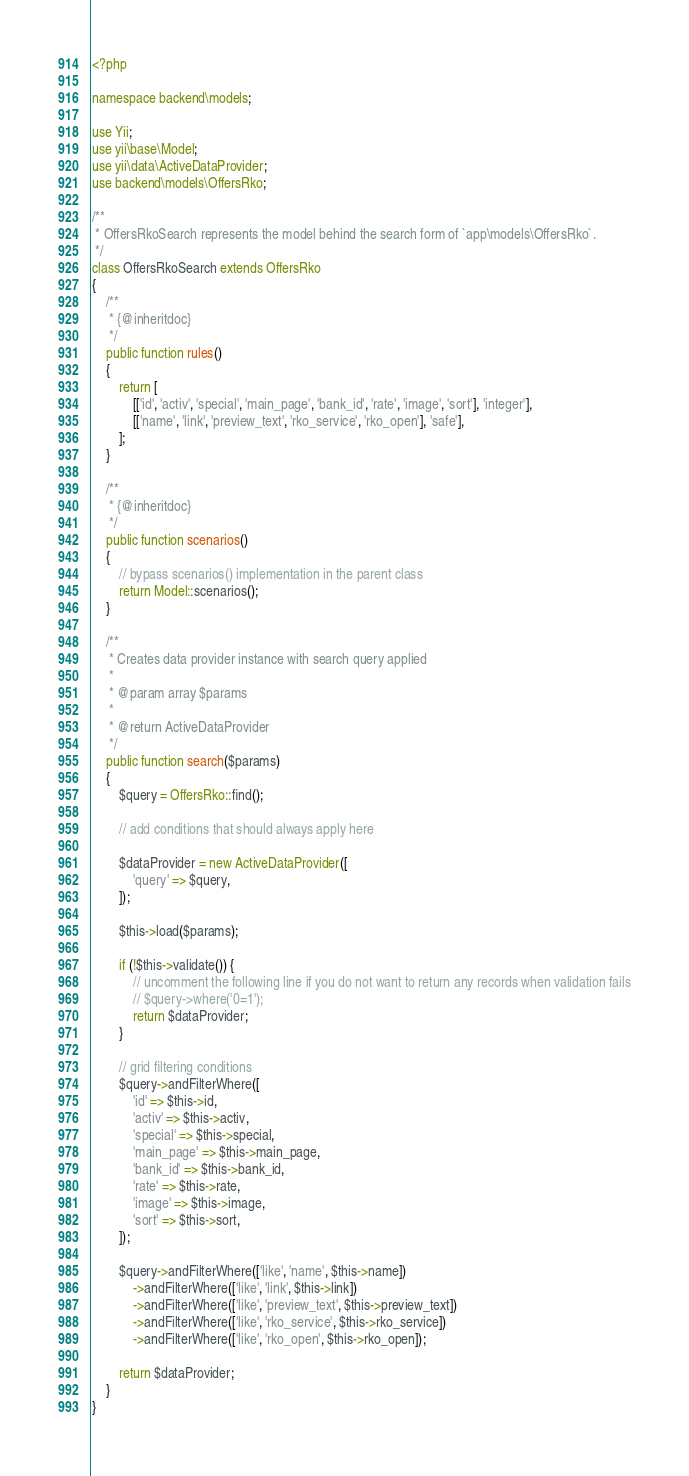Convert code to text. <code><loc_0><loc_0><loc_500><loc_500><_PHP_><?php

namespace backend\models;

use Yii;
use yii\base\Model;
use yii\data\ActiveDataProvider;
use backend\models\OffersRko;

/**
 * OffersRkoSearch represents the model behind the search form of `app\models\OffersRko`.
 */
class OffersRkoSearch extends OffersRko
{
    /**
     * {@inheritdoc}
     */
    public function rules()
    {
        return [
            [['id', 'activ', 'special', 'main_page', 'bank_id', 'rate', 'image', 'sort'], 'integer'],
            [['name', 'link', 'preview_text', 'rko_service', 'rko_open'], 'safe'],
        ];
    }

    /**
     * {@inheritdoc}
     */
    public function scenarios()
    {
        // bypass scenarios() implementation in the parent class
        return Model::scenarios();
    }

    /**
     * Creates data provider instance with search query applied
     *
     * @param array $params
     *
     * @return ActiveDataProvider
     */
    public function search($params)
    {
        $query = OffersRko::find();

        // add conditions that should always apply here

        $dataProvider = new ActiveDataProvider([
            'query' => $query,
        ]);

        $this->load($params);

        if (!$this->validate()) {
            // uncomment the following line if you do not want to return any records when validation fails
            // $query->where('0=1');
            return $dataProvider;
        }

        // grid filtering conditions
        $query->andFilterWhere([
            'id' => $this->id,
            'activ' => $this->activ,
            'special' => $this->special,
            'main_page' => $this->main_page,
            'bank_id' => $this->bank_id,
            'rate' => $this->rate,
            'image' => $this->image,
            'sort' => $this->sort,
        ]);

        $query->andFilterWhere(['like', 'name', $this->name])
            ->andFilterWhere(['like', 'link', $this->link])
            ->andFilterWhere(['like', 'preview_text', $this->preview_text])
            ->andFilterWhere(['like', 'rko_service', $this->rko_service])
            ->andFilterWhere(['like', 'rko_open', $this->rko_open]);

        return $dataProvider;
    }
}
</code> 